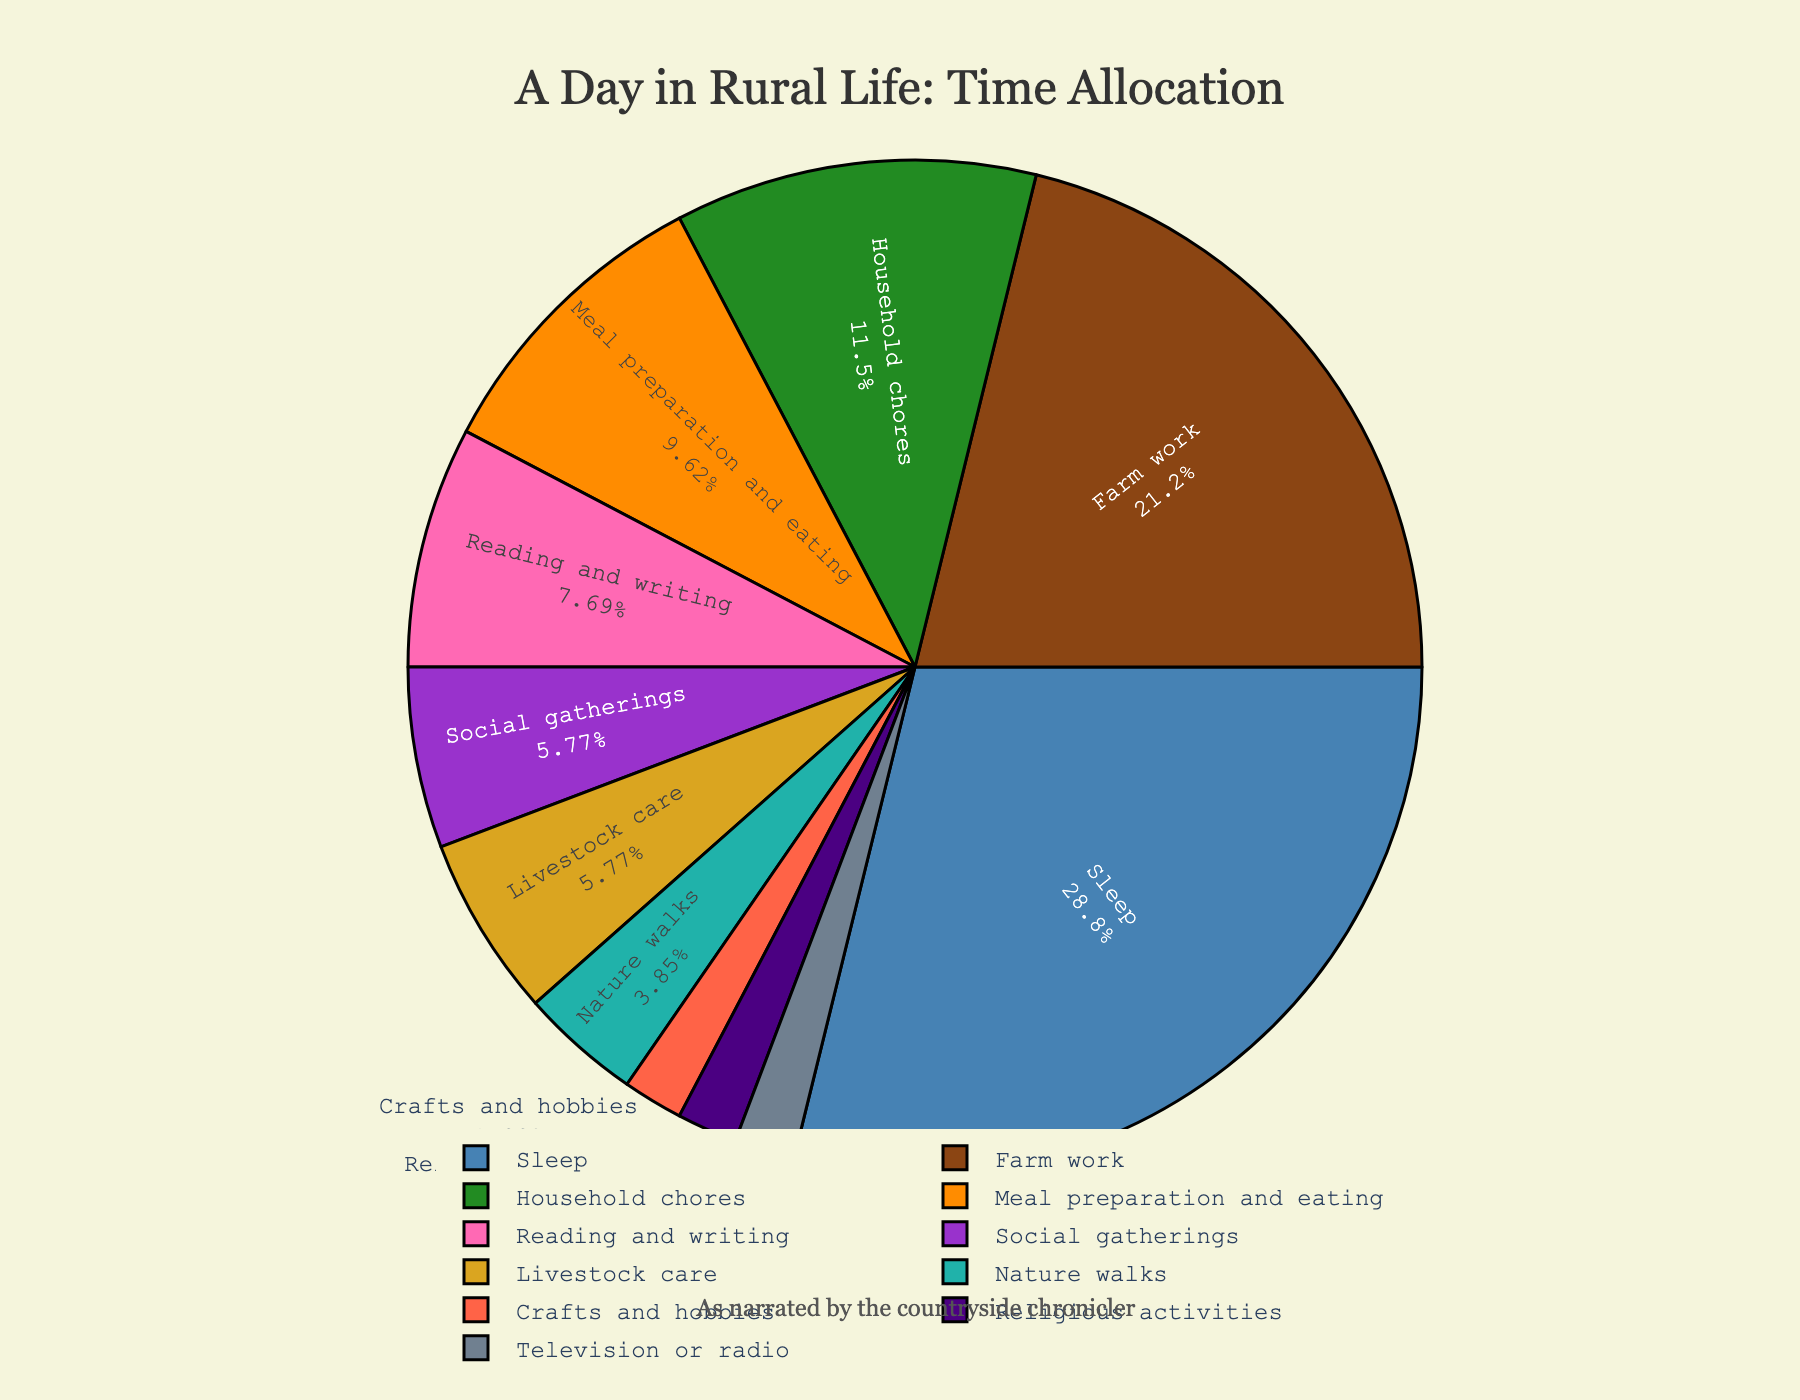Which activity consumes the largest portion of the day? The figure shows a pie chart where each activity is represented by a section of the pie. The activity with the largest section is clearly labeled.
Answer: Sleep How many hours are spent on farm work compared to household chores? The pie chart’s sections are labeled with the activities and their respective durations. Farm work is labeled with 5.5 hours and household chores with 3.0 hours.
Answer: 5.5 hours vs 3.0 hours If you combine livestock care, social gatherings, and nature walks, what percentage of the day do they represent? First, find the sections labeled livestock care (1.5 hours), social gatherings (1.5 hours), and nature walks (1.0 hours). Sum these hours to get 4.0 hours. Since the total hours in a day displayed on the pie chart is 24, the percentage is (4.0/24) * 100 = 16.67%.
Answer: 16.67% Which activity takes less time: crafts and hobbies or watching television or radio? The pie chart shows that both crafts and hobbies and television or radio have segments, each labeled with their respective durations (0.5 hours). Comparing these, we see there is no time difference as both are equal.
Answer: Equal Are more hours spent on meal preparation and eating or on reading and writing? From the pie chart, locate the sections for meal preparation and eating (2.5 hours) and reading and writing (2.0 hours). Compare the hours to see which one is more.
Answer: Meal preparation and eating What's the combined percentage of time spent on sleep and meal preparation and eating? The pie chart shows the durations for sleep (7.5 hours) and meal preparation and eating (2.5 hours). Sum these hours to get 10 hours. Since the total hours displayed on the pie chart is 24, the percentage is (10/24) * 100 = 41.67%.
Answer: 41.67% Which activities have the least time allocation on the chart? Review the pie chart for the smallest sections labeled with the least hours. Crafts and hobbies, religious activities, and television or radio each have 0.5 hours.
Answer: Crafts and hobbies, religious activities, television or radio Visually, which segment appears to be green, and what activity does it represent? Identify the green-colored segment on the pie chart. The label associated with this segment is looked at directly in the figure.
Answer: Household chores 